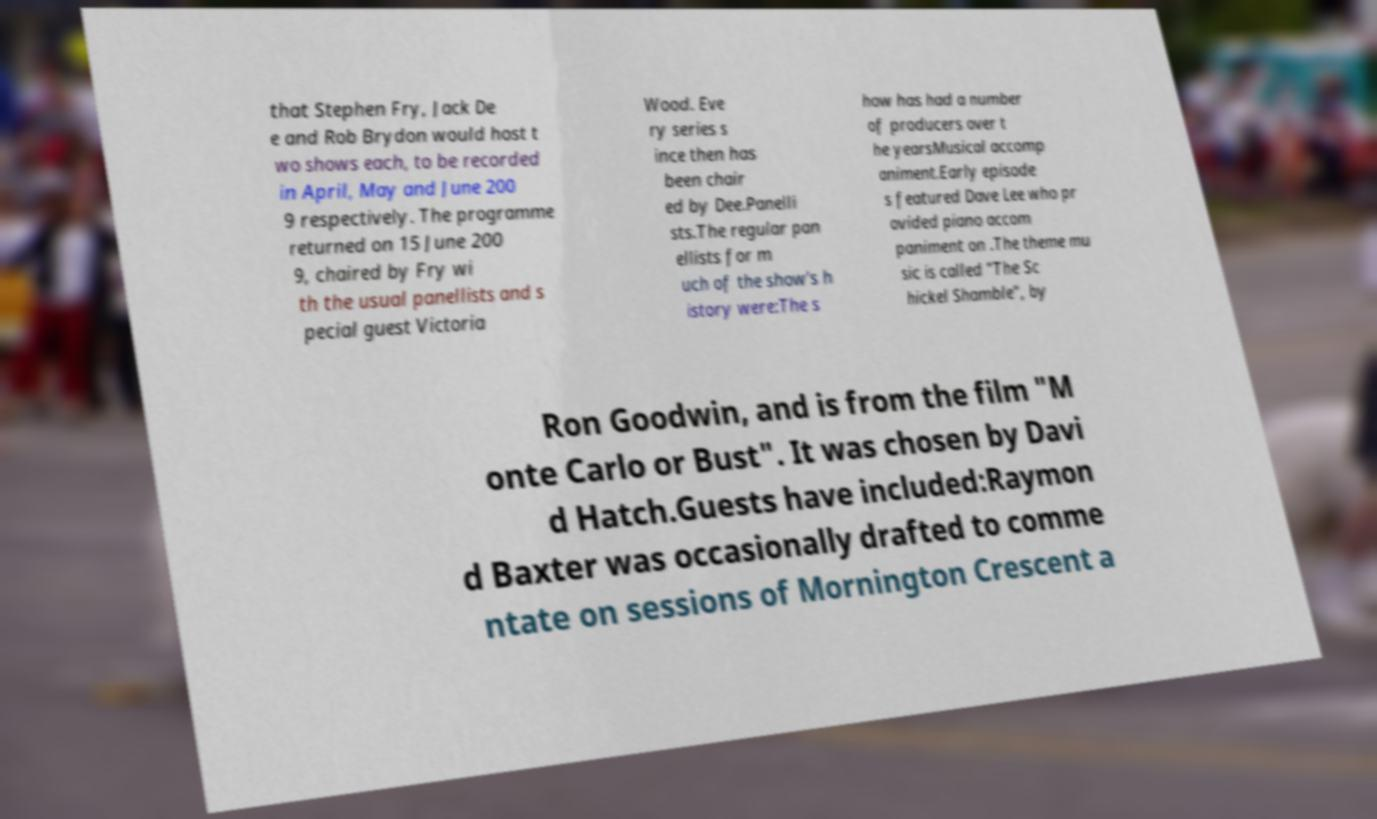Please read and relay the text visible in this image. What does it say? that Stephen Fry, Jack De e and Rob Brydon would host t wo shows each, to be recorded in April, May and June 200 9 respectively. The programme returned on 15 June 200 9, chaired by Fry wi th the usual panellists and s pecial guest Victoria Wood. Eve ry series s ince then has been chair ed by Dee.Panelli sts.The regular pan ellists for m uch of the show's h istory were:The s how has had a number of producers over t he yearsMusical accomp animent.Early episode s featured Dave Lee who pr ovided piano accom paniment on .The theme mu sic is called "The Sc hickel Shamble", by Ron Goodwin, and is from the film "M onte Carlo or Bust". It was chosen by Davi d Hatch.Guests have included:Raymon d Baxter was occasionally drafted to comme ntate on sessions of Mornington Crescent a 